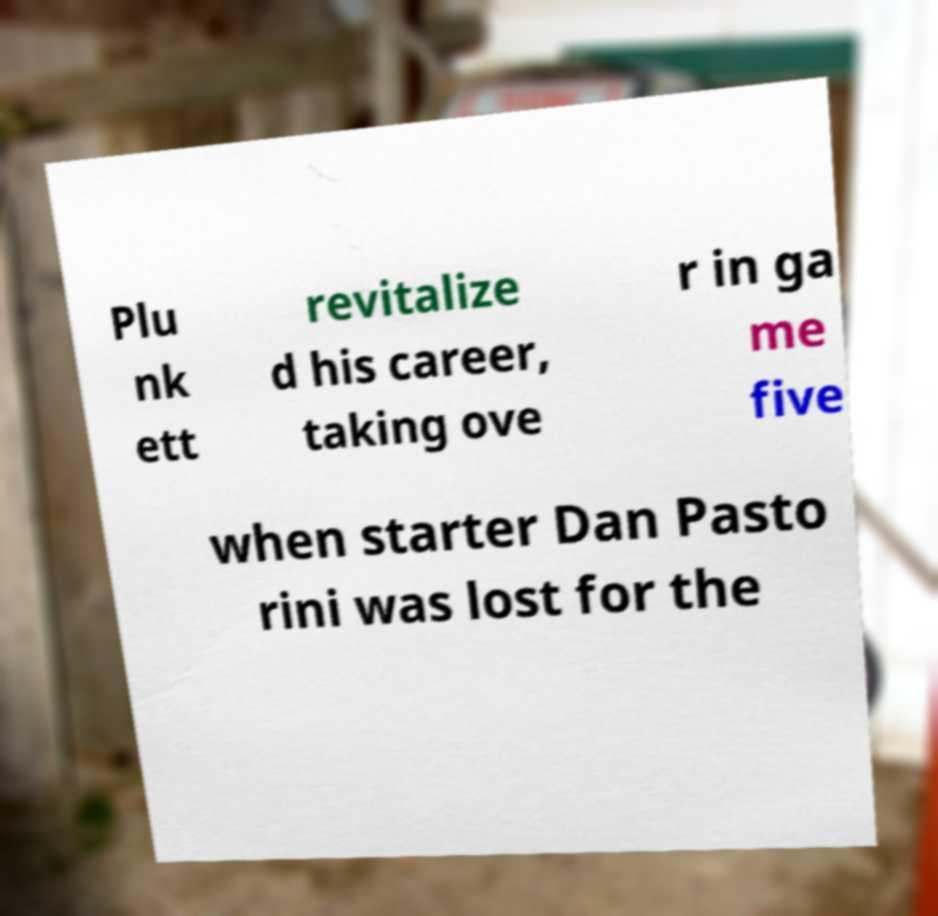Can you read and provide the text displayed in the image?This photo seems to have some interesting text. Can you extract and type it out for me? Plu nk ett revitalize d his career, taking ove r in ga me five when starter Dan Pasto rini was lost for the 